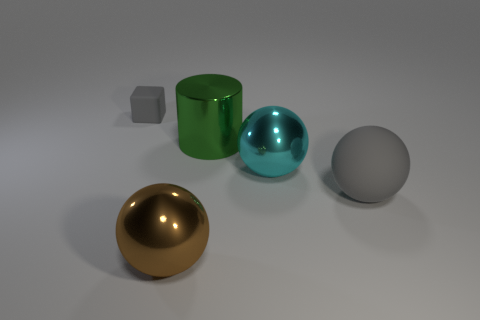Subtract all gray balls. How many balls are left? 2 Subtract all gray balls. How many balls are left? 2 Add 3 gray cylinders. How many objects exist? 8 Add 1 large brown balls. How many large brown balls exist? 2 Subtract 0 cyan cylinders. How many objects are left? 5 Subtract all balls. How many objects are left? 2 Subtract 1 cylinders. How many cylinders are left? 0 Subtract all brown blocks. Subtract all cyan cylinders. How many blocks are left? 1 Subtract all green cubes. How many cyan spheres are left? 1 Subtract all blocks. Subtract all rubber spheres. How many objects are left? 3 